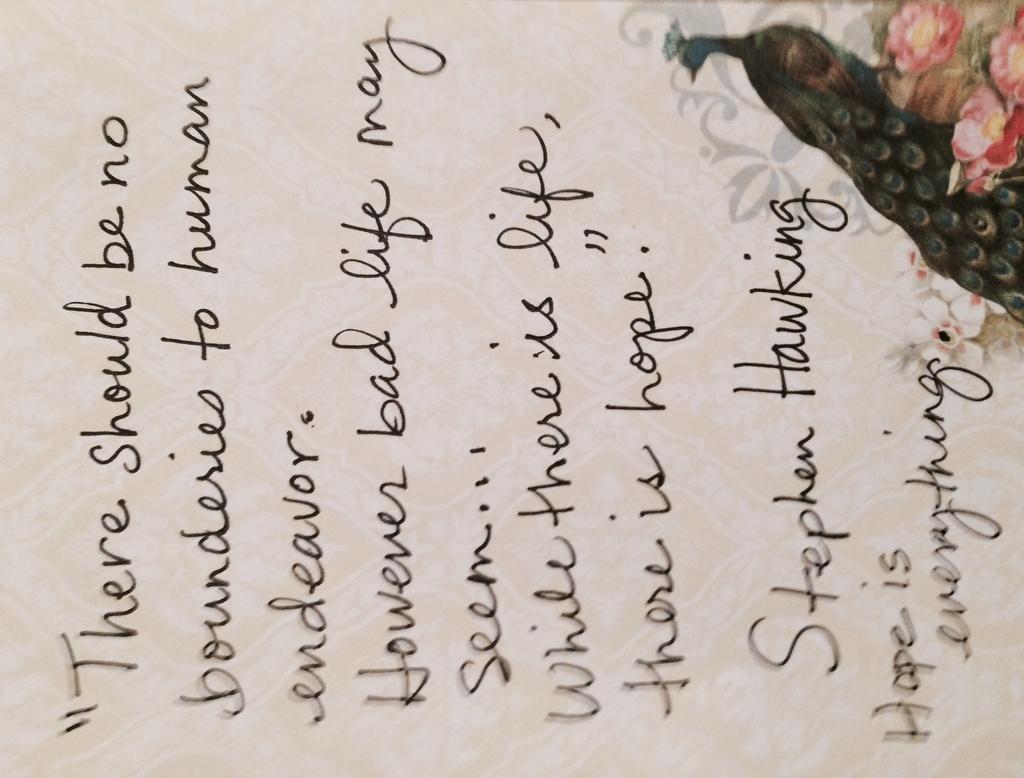Describe this image in one or two sentences. In the image there is a paper with something written on it. And there is a peacock and flowers images on the paper. 